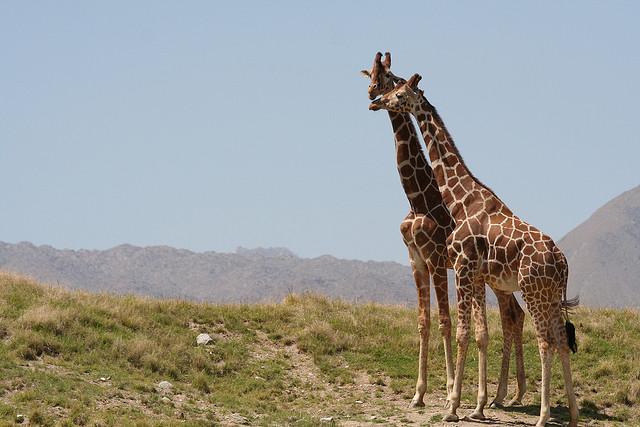How many animals are there?
Give a very brief answer. 2. How many species of animals do you see?
Give a very brief answer. 1. How many things are flying in this picture?
Give a very brief answer. 0. How many giraffes are seen here?
Give a very brief answer. 2. How many giraffes can be seen?
Give a very brief answer. 2. 